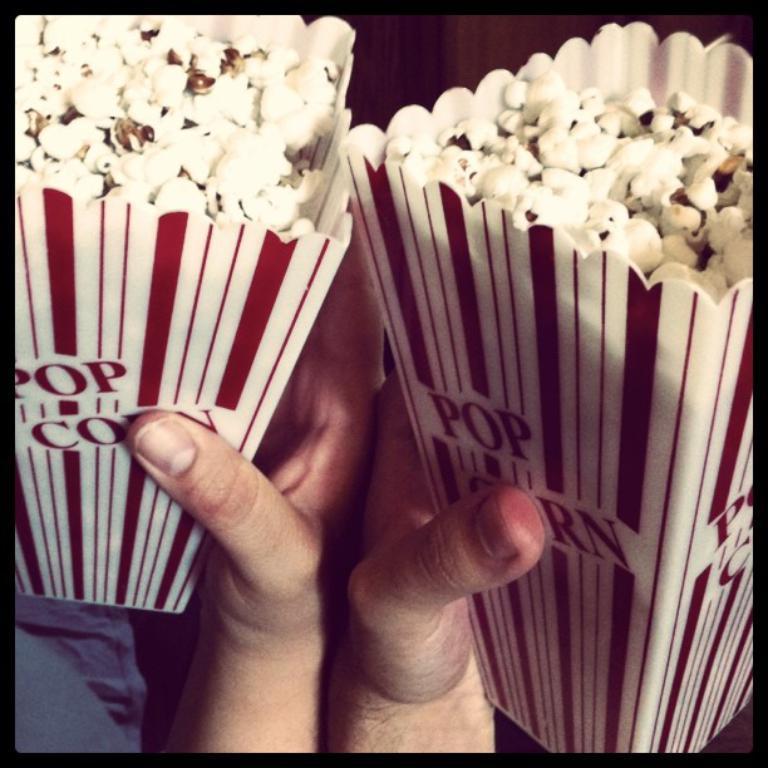Can you describe this image briefly? In this image I can see two hands holding popcorn packets which are in white and red colors. 